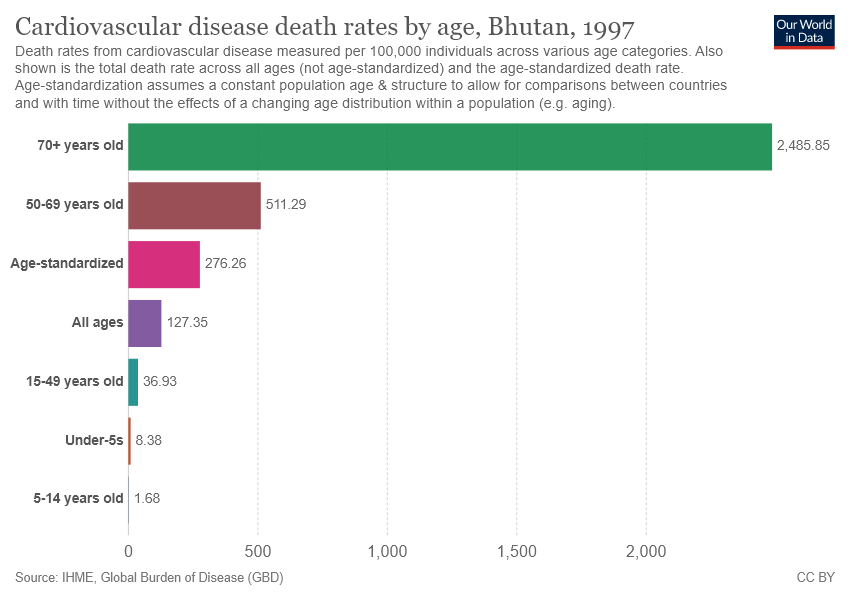Highlight a few significant elements in this photo. The smallest difference between two bars is 6.7... The longest bar is over 70 years old. 